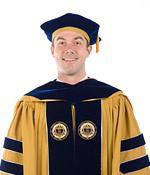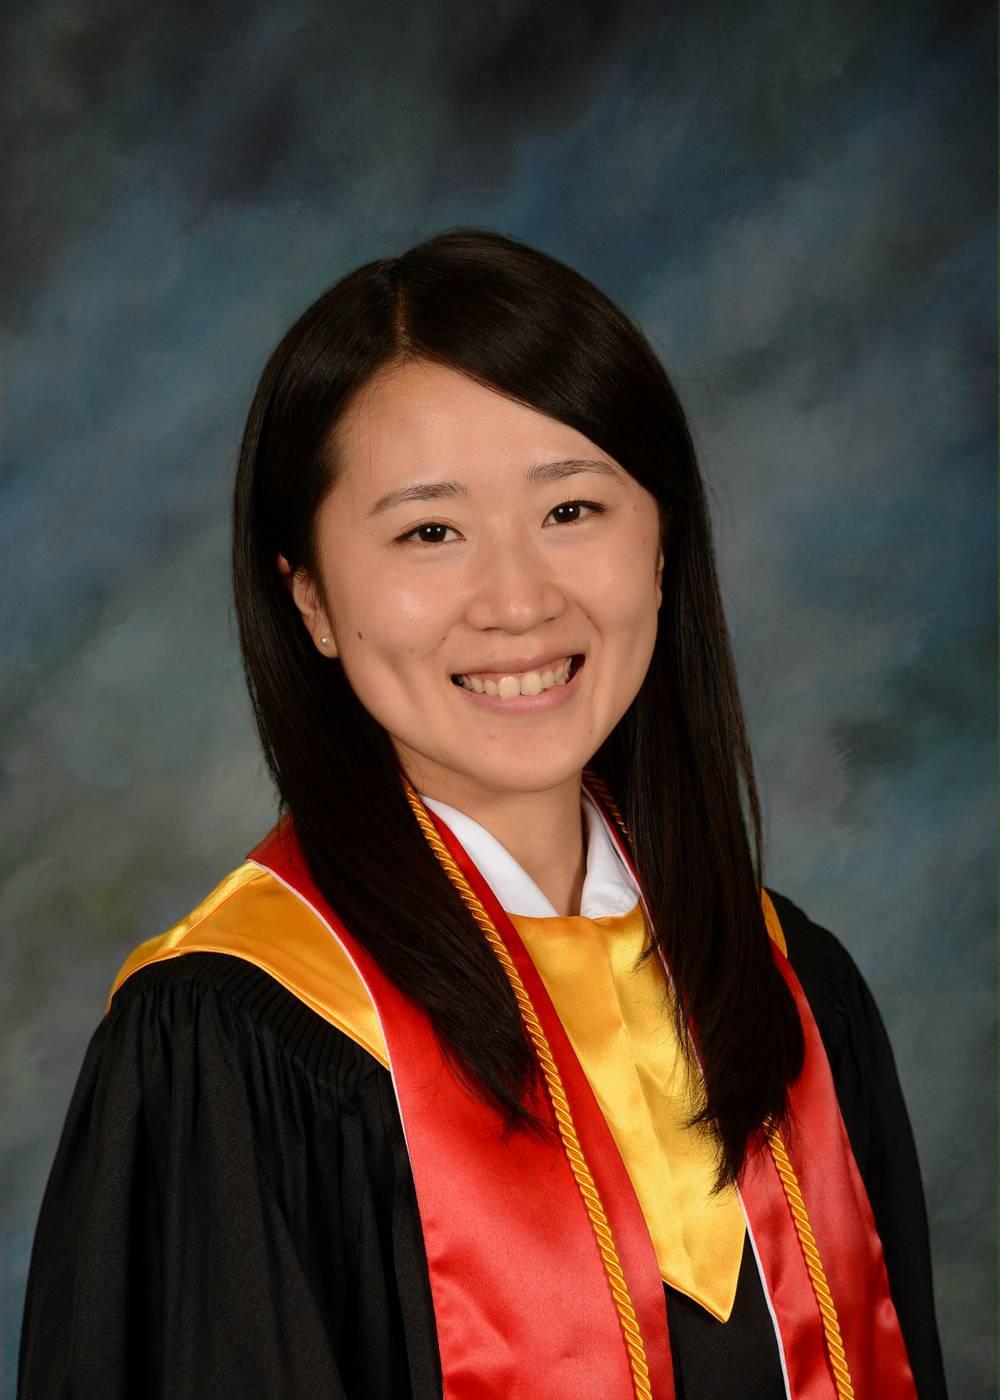The first image is the image on the left, the second image is the image on the right. Considering the images on both sides, is "A mona is holding the tassel on her mortarboard." valid? Answer yes or no. No. The first image is the image on the left, the second image is the image on the right. Evaluate the accuracy of this statement regarding the images: "One image shows a brunette female grasping the black tassel on her graduation cap.". Is it true? Answer yes or no. No. 